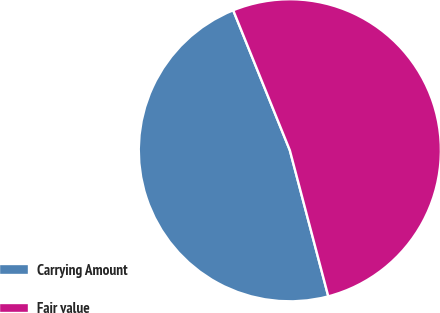Convert chart. <chart><loc_0><loc_0><loc_500><loc_500><pie_chart><fcel>Carrying Amount<fcel>Fair value<nl><fcel>47.98%<fcel>52.02%<nl></chart> 